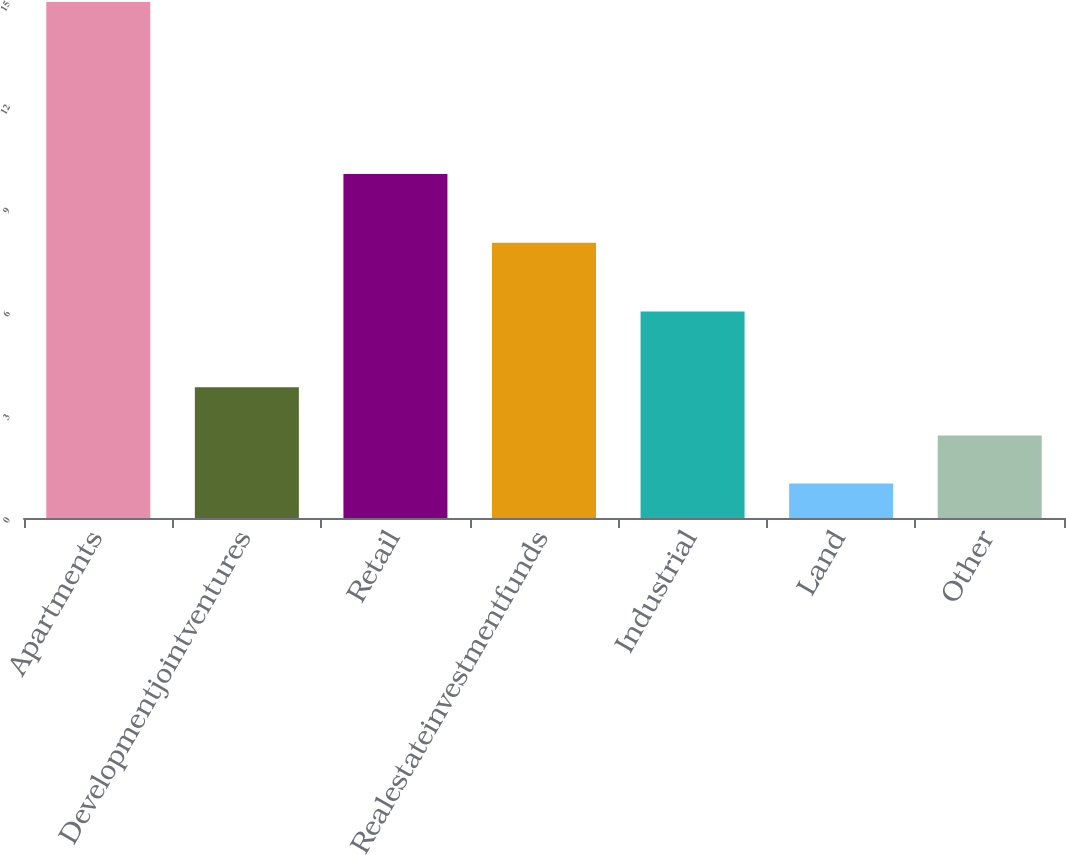Convert chart. <chart><loc_0><loc_0><loc_500><loc_500><bar_chart><fcel>Apartments<fcel>Developmentjointventures<fcel>Retail<fcel>Realestateinvestmentfunds<fcel>Industrial<fcel>Land<fcel>Other<nl><fcel>15<fcel>3.8<fcel>10<fcel>8<fcel>6<fcel>1<fcel>2.4<nl></chart> 